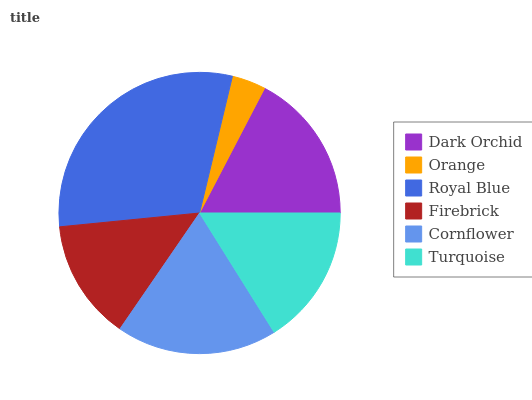Is Orange the minimum?
Answer yes or no. Yes. Is Royal Blue the maximum?
Answer yes or no. Yes. Is Royal Blue the minimum?
Answer yes or no. No. Is Orange the maximum?
Answer yes or no. No. Is Royal Blue greater than Orange?
Answer yes or no. Yes. Is Orange less than Royal Blue?
Answer yes or no. Yes. Is Orange greater than Royal Blue?
Answer yes or no. No. Is Royal Blue less than Orange?
Answer yes or no. No. Is Dark Orchid the high median?
Answer yes or no. Yes. Is Turquoise the low median?
Answer yes or no. Yes. Is Turquoise the high median?
Answer yes or no. No. Is Cornflower the low median?
Answer yes or no. No. 